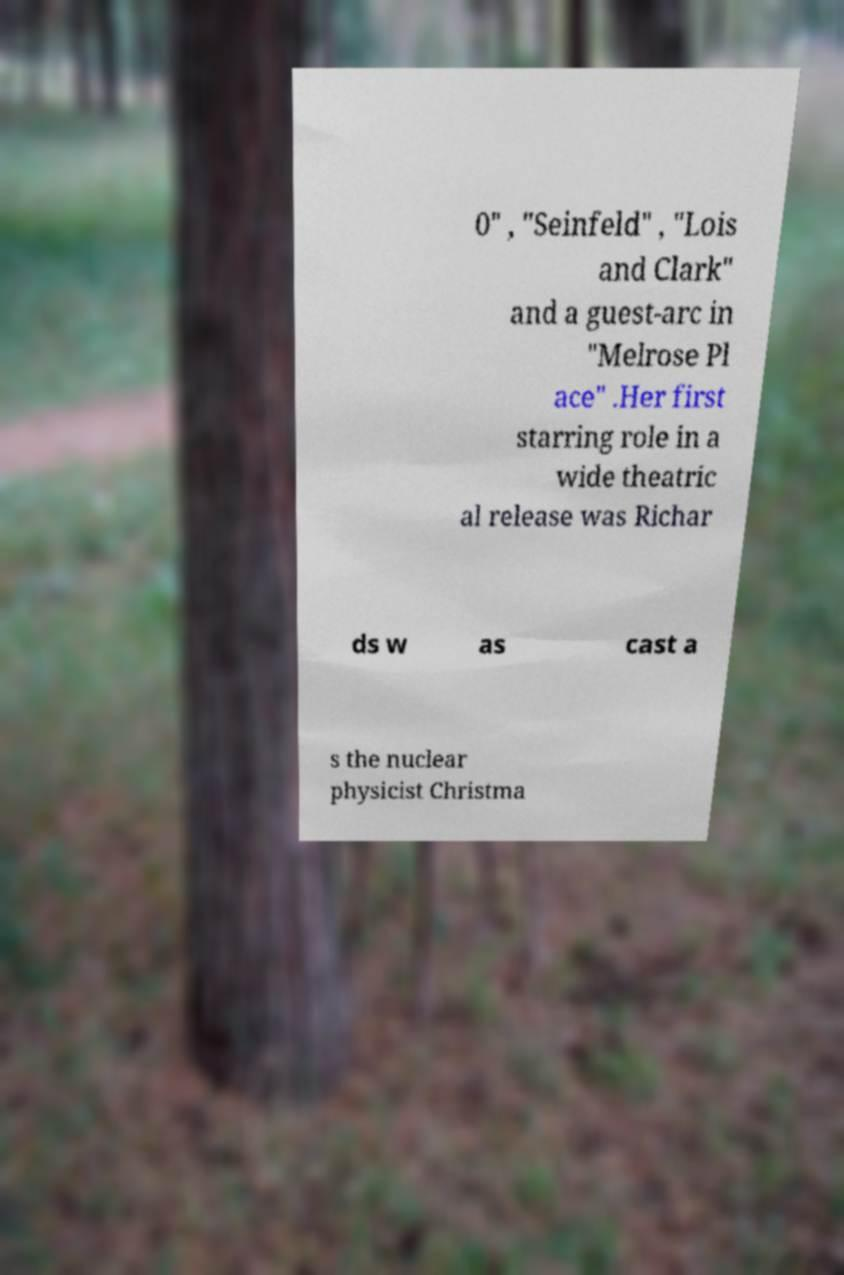There's text embedded in this image that I need extracted. Can you transcribe it verbatim? 0" , "Seinfeld" , "Lois and Clark" and a guest-arc in "Melrose Pl ace" .Her first starring role in a wide theatric al release was Richar ds w as cast a s the nuclear physicist Christma 